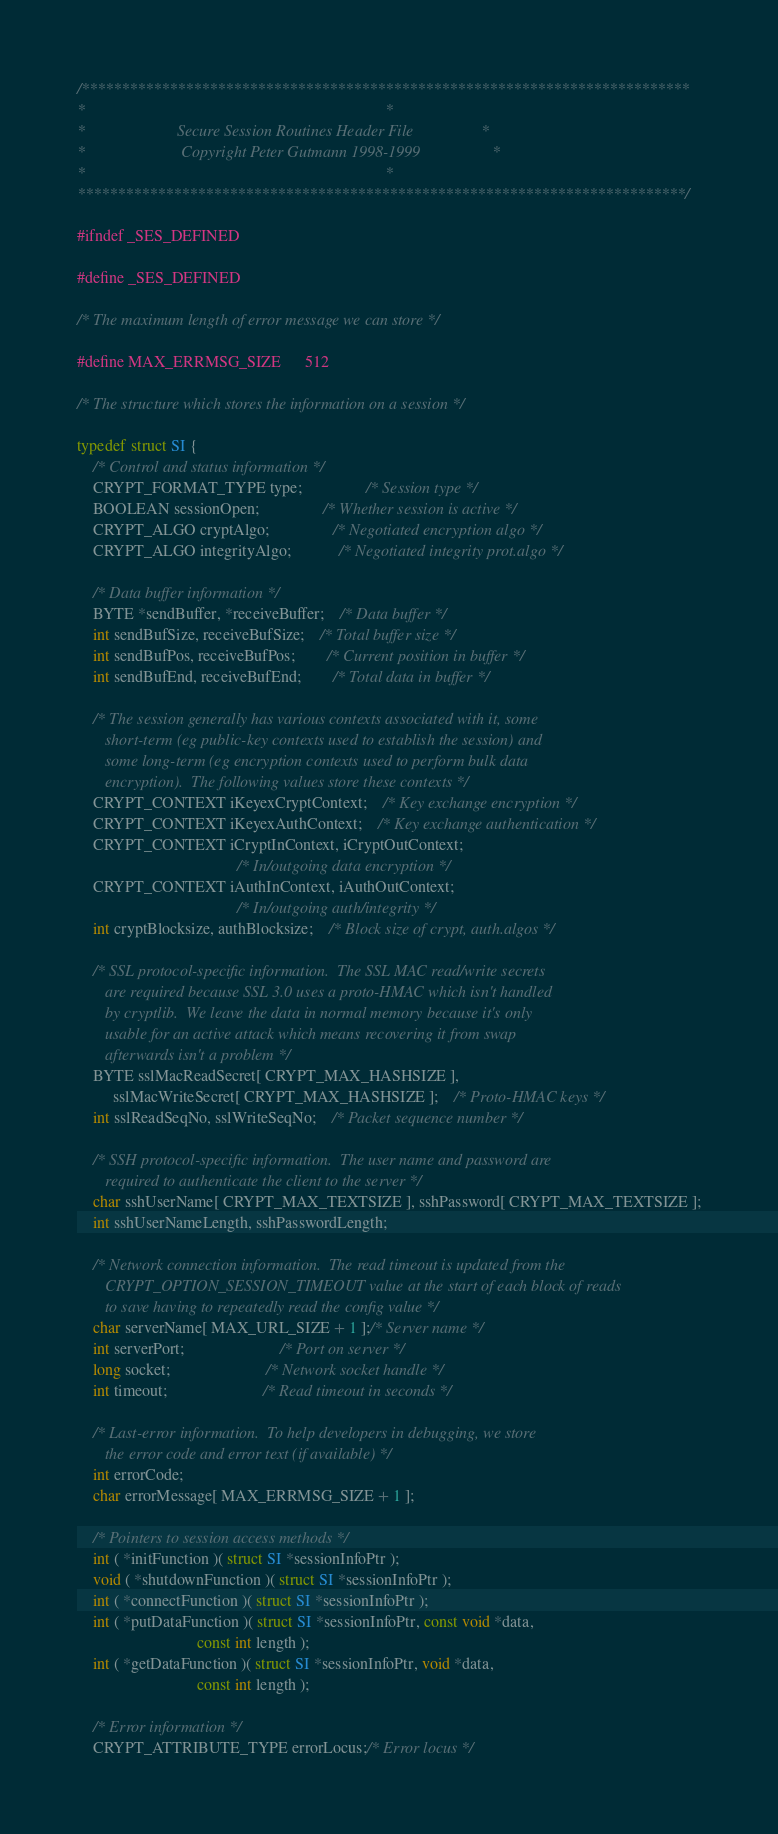<code> <loc_0><loc_0><loc_500><loc_500><_C_>/****************************************************************************
*																			*
*						Secure Session Routines Header File					*
*						 Copyright Peter Gutmann 1998-1999					*
*																			*
****************************************************************************/

#ifndef _SES_DEFINED

#define _SES_DEFINED

/* The maximum length of error message we can store */

#define MAX_ERRMSG_SIZE		512

/* The structure which stores the information on a session */

typedef struct SI {
	/* Control and status information */
	CRYPT_FORMAT_TYPE type;				/* Session type */
	BOOLEAN sessionOpen;				/* Whether session is active */
	CRYPT_ALGO cryptAlgo;				/* Negotiated encryption algo */
	CRYPT_ALGO integrityAlgo;			/* Negotiated integrity prot.algo */

	/* Data buffer information */
	BYTE *sendBuffer, *receiveBuffer;	/* Data buffer */
	int sendBufSize, receiveBufSize;	/* Total buffer size */
	int sendBufPos, receiveBufPos;		/* Current position in buffer */
	int sendBufEnd, receiveBufEnd;		/* Total data in buffer */

	/* The session generally has various contexts associated with it, some
	   short-term (eg public-key contexts used to establish the session) and
	   some long-term (eg encryption contexts used to perform bulk data
	   encryption).  The following values store these contexts */
	CRYPT_CONTEXT iKeyexCryptContext;	/* Key exchange encryption */
	CRYPT_CONTEXT iKeyexAuthContext;	/* Key exchange authentication */
	CRYPT_CONTEXT iCryptInContext, iCryptOutContext;
										/* In/outgoing data encryption */
	CRYPT_CONTEXT iAuthInContext, iAuthOutContext;
										/* In/outgoing auth/integrity */
	int cryptBlocksize, authBlocksize;	/* Block size of crypt, auth.algos */

	/* SSL protocol-specific information.  The SSL MAC read/write secrets 
	   are required because SSL 3.0 uses a proto-HMAC which isn't handled 
	   by cryptlib.  We leave the data in normal memory because it's only
	   usable for an active attack which means recovering it from swap
	   afterwards isn't a problem */
	BYTE sslMacReadSecret[ CRYPT_MAX_HASHSIZE ],
		 sslMacWriteSecret[ CRYPT_MAX_HASHSIZE ];	/* Proto-HMAC keys */
	int sslReadSeqNo, sslWriteSeqNo;	/* Packet sequence number */

	/* SSH protocol-specific information.  The user name and password are
	   required to authenticate the client to the server */
	char sshUserName[ CRYPT_MAX_TEXTSIZE ], sshPassword[ CRYPT_MAX_TEXTSIZE ];
	int sshUserNameLength, sshPasswordLength;

	/* Network connection information.  The read timeout is updated from the
	   CRYPT_OPTION_SESSION_TIMEOUT value at the start of each block of reads
	   to save having to repeatedly read the config value */
	char serverName[ MAX_URL_SIZE + 1 ];/* Server name */
	int serverPort;						/* Port on server */
	long socket;						/* Network socket handle */
	int timeout;						/* Read timeout in seconds */

	/* Last-error information.  To help developers in debugging, we store
	   the error code and error text (if available) */
	int errorCode;
	char errorMessage[ MAX_ERRMSG_SIZE + 1 ];

	/* Pointers to session access methods */
	int ( *initFunction )( struct SI *sessionInfoPtr );
	void ( *shutdownFunction )( struct SI *sessionInfoPtr );
	int ( *connectFunction )( struct SI *sessionInfoPtr );
	int ( *putDataFunction )( struct SI *sessionInfoPtr, const void *data,
							  const int length );
	int ( *getDataFunction )( struct SI *sessionInfoPtr, void *data,
							  const int length );

	/* Error information */
	CRYPT_ATTRIBUTE_TYPE errorLocus;/* Error locus */</code> 